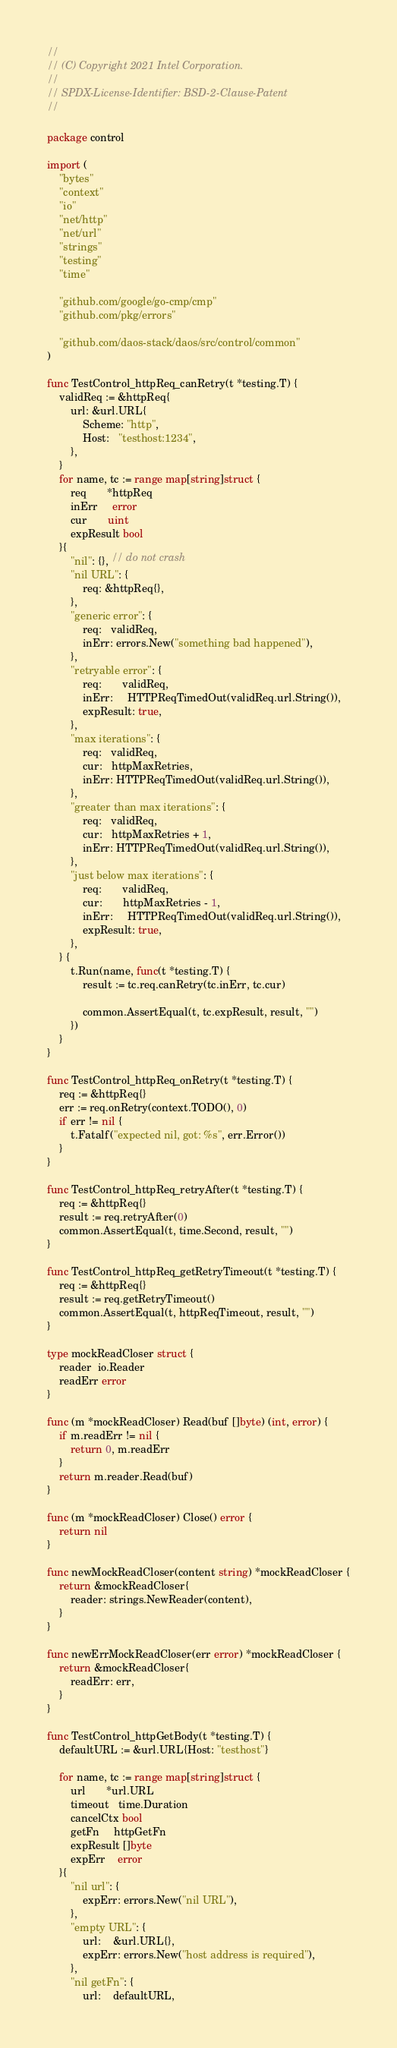Convert code to text. <code><loc_0><loc_0><loc_500><loc_500><_Go_>//
// (C) Copyright 2021 Intel Corporation.
//
// SPDX-License-Identifier: BSD-2-Clause-Patent
//

package control

import (
	"bytes"
	"context"
	"io"
	"net/http"
	"net/url"
	"strings"
	"testing"
	"time"

	"github.com/google/go-cmp/cmp"
	"github.com/pkg/errors"

	"github.com/daos-stack/daos/src/control/common"
)

func TestControl_httpReq_canRetry(t *testing.T) {
	validReq := &httpReq{
		url: &url.URL{
			Scheme: "http",
			Host:   "testhost:1234",
		},
	}
	for name, tc := range map[string]struct {
		req       *httpReq
		inErr     error
		cur       uint
		expResult bool
	}{
		"nil": {}, // do not crash
		"nil URL": {
			req: &httpReq{},
		},
		"generic error": {
			req:   validReq,
			inErr: errors.New("something bad happened"),
		},
		"retryable error": {
			req:       validReq,
			inErr:     HTTPReqTimedOut(validReq.url.String()),
			expResult: true,
		},
		"max iterations": {
			req:   validReq,
			cur:   httpMaxRetries,
			inErr: HTTPReqTimedOut(validReq.url.String()),
		},
		"greater than max iterations": {
			req:   validReq,
			cur:   httpMaxRetries + 1,
			inErr: HTTPReqTimedOut(validReq.url.String()),
		},
		"just below max iterations": {
			req:       validReq,
			cur:       httpMaxRetries - 1,
			inErr:     HTTPReqTimedOut(validReq.url.String()),
			expResult: true,
		},
	} {
		t.Run(name, func(t *testing.T) {
			result := tc.req.canRetry(tc.inErr, tc.cur)

			common.AssertEqual(t, tc.expResult, result, "")
		})
	}
}

func TestControl_httpReq_onRetry(t *testing.T) {
	req := &httpReq{}
	err := req.onRetry(context.TODO(), 0)
	if err != nil {
		t.Fatalf("expected nil, got: %s", err.Error())
	}
}

func TestControl_httpReq_retryAfter(t *testing.T) {
	req := &httpReq{}
	result := req.retryAfter(0)
	common.AssertEqual(t, time.Second, result, "")
}

func TestControl_httpReq_getRetryTimeout(t *testing.T) {
	req := &httpReq{}
	result := req.getRetryTimeout()
	common.AssertEqual(t, httpReqTimeout, result, "")
}

type mockReadCloser struct {
	reader  io.Reader
	readErr error
}

func (m *mockReadCloser) Read(buf []byte) (int, error) {
	if m.readErr != nil {
		return 0, m.readErr
	}
	return m.reader.Read(buf)
}

func (m *mockReadCloser) Close() error {
	return nil
}

func newMockReadCloser(content string) *mockReadCloser {
	return &mockReadCloser{
		reader: strings.NewReader(content),
	}
}

func newErrMockReadCloser(err error) *mockReadCloser {
	return &mockReadCloser{
		readErr: err,
	}
}

func TestControl_httpGetBody(t *testing.T) {
	defaultURL := &url.URL{Host: "testhost"}

	for name, tc := range map[string]struct {
		url       *url.URL
		timeout   time.Duration
		cancelCtx bool
		getFn     httpGetFn
		expResult []byte
		expErr    error
	}{
		"nil url": {
			expErr: errors.New("nil URL"),
		},
		"empty URL": {
			url:    &url.URL{},
			expErr: errors.New("host address is required"),
		},
		"nil getFn": {
			url:    defaultURL,</code> 